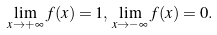Convert formula to latex. <formula><loc_0><loc_0><loc_500><loc_500>\lim _ { x \rightarrow + \infty } f ( x ) = 1 , \, \lim _ { x \rightarrow - \infty } f ( x ) = 0 .</formula> 